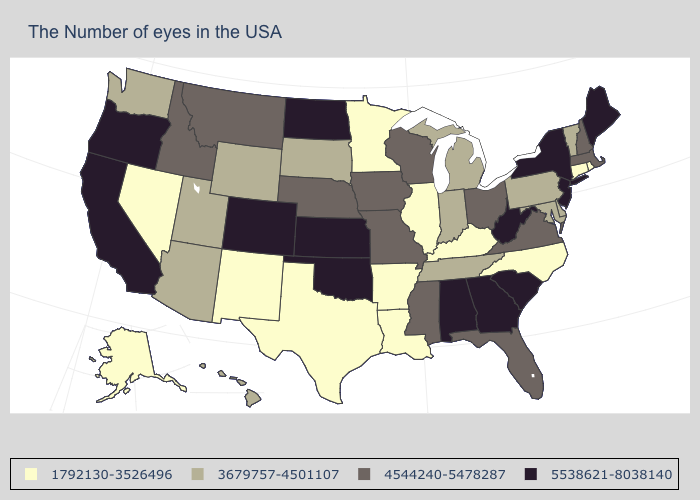Does Vermont have a higher value than New York?
Write a very short answer. No. What is the value of Vermont?
Write a very short answer. 3679757-4501107. Name the states that have a value in the range 1792130-3526496?
Give a very brief answer. Rhode Island, Connecticut, North Carolina, Kentucky, Illinois, Louisiana, Arkansas, Minnesota, Texas, New Mexico, Nevada, Alaska. Name the states that have a value in the range 5538621-8038140?
Short answer required. Maine, New York, New Jersey, South Carolina, West Virginia, Georgia, Alabama, Kansas, Oklahoma, North Dakota, Colorado, California, Oregon. Does the map have missing data?
Give a very brief answer. No. What is the value of New York?
Concise answer only. 5538621-8038140. Name the states that have a value in the range 1792130-3526496?
Concise answer only. Rhode Island, Connecticut, North Carolina, Kentucky, Illinois, Louisiana, Arkansas, Minnesota, Texas, New Mexico, Nevada, Alaska. What is the value of Massachusetts?
Be succinct. 4544240-5478287. What is the highest value in the USA?
Keep it brief. 5538621-8038140. Does the map have missing data?
Answer briefly. No. Among the states that border Montana , does Idaho have the lowest value?
Keep it brief. No. Which states have the highest value in the USA?
Give a very brief answer. Maine, New York, New Jersey, South Carolina, West Virginia, Georgia, Alabama, Kansas, Oklahoma, North Dakota, Colorado, California, Oregon. Does the map have missing data?
Write a very short answer. No. What is the value of Connecticut?
Give a very brief answer. 1792130-3526496. Does the map have missing data?
Quick response, please. No. 